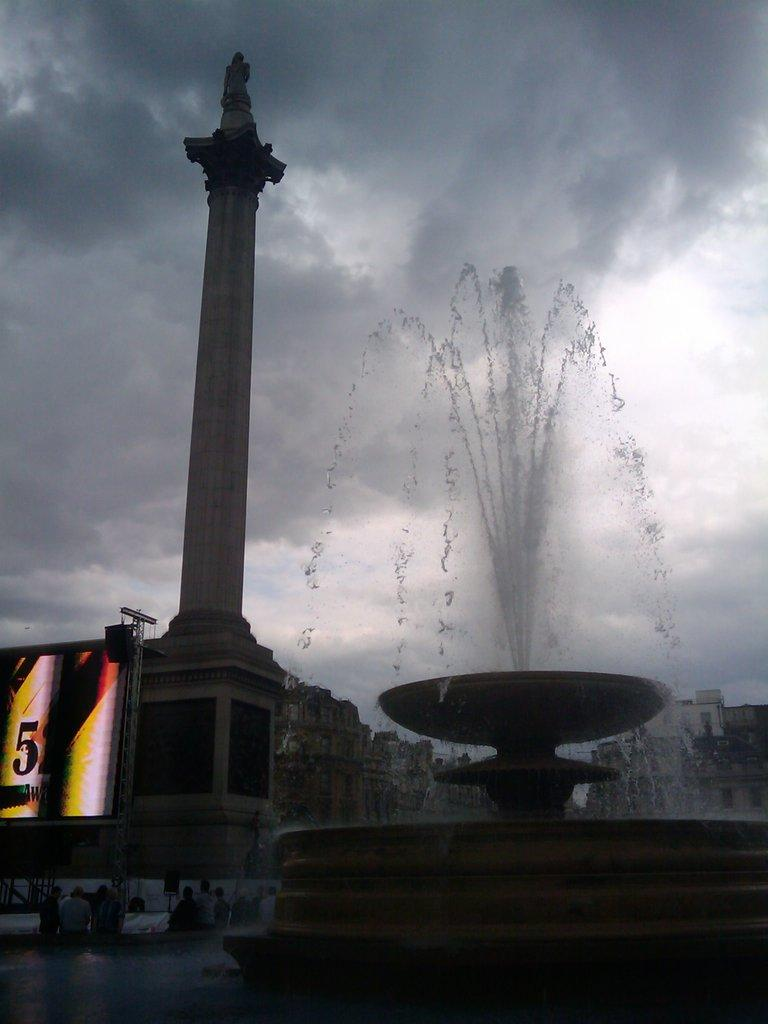Provide a one-sentence caption for the provided image. A lit sign with the number 52 is set up next to a pillar and a fountain. 